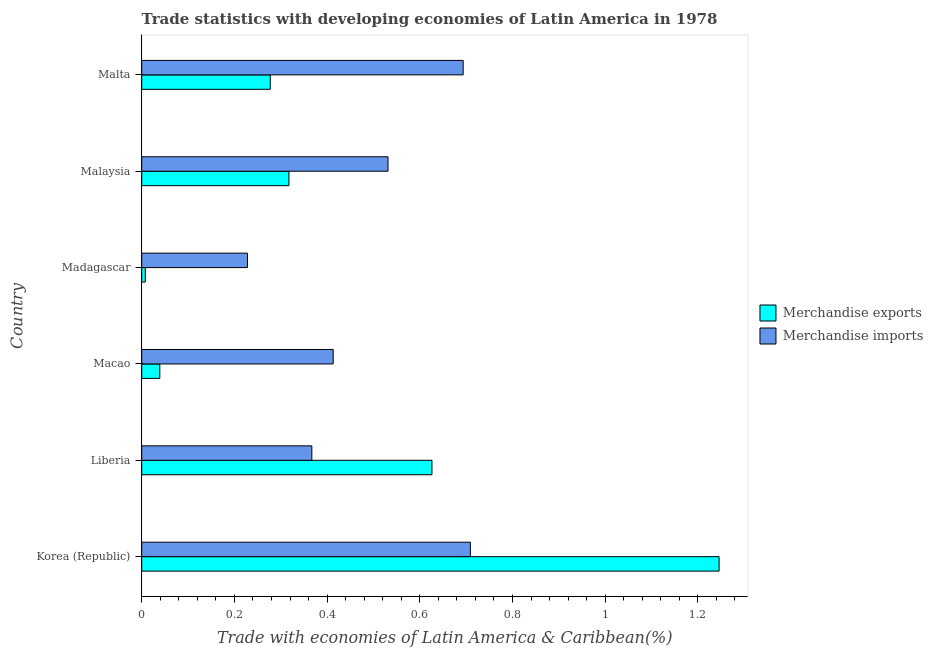How many different coloured bars are there?
Keep it short and to the point. 2. How many groups of bars are there?
Provide a short and direct response. 6. How many bars are there on the 5th tick from the top?
Keep it short and to the point. 2. How many bars are there on the 6th tick from the bottom?
Your answer should be compact. 2. What is the label of the 4th group of bars from the top?
Your answer should be very brief. Macao. What is the merchandise imports in Malta?
Provide a short and direct response. 0.69. Across all countries, what is the maximum merchandise imports?
Your answer should be very brief. 0.71. Across all countries, what is the minimum merchandise exports?
Your answer should be very brief. 0.01. In which country was the merchandise exports minimum?
Ensure brevity in your answer.  Madagascar. What is the total merchandise imports in the graph?
Ensure brevity in your answer.  2.94. What is the difference between the merchandise exports in Korea (Republic) and that in Malaysia?
Offer a very short reply. 0.93. What is the difference between the merchandise exports in Madagascar and the merchandise imports in Liberia?
Your answer should be compact. -0.36. What is the average merchandise exports per country?
Provide a short and direct response. 0.42. What is the difference between the merchandise exports and merchandise imports in Korea (Republic)?
Provide a short and direct response. 0.54. In how many countries, is the merchandise imports greater than 1 %?
Ensure brevity in your answer.  0. What is the ratio of the merchandise imports in Korea (Republic) to that in Liberia?
Provide a short and direct response. 1.93. Is the difference between the merchandise imports in Macao and Malta greater than the difference between the merchandise exports in Macao and Malta?
Your answer should be very brief. No. What is the difference between the highest and the second highest merchandise exports?
Offer a very short reply. 0.62. What is the difference between the highest and the lowest merchandise imports?
Your response must be concise. 0.48. In how many countries, is the merchandise exports greater than the average merchandise exports taken over all countries?
Your response must be concise. 2. What does the 1st bar from the top in Macao represents?
Offer a terse response. Merchandise imports. What does the 1st bar from the bottom in Liberia represents?
Offer a terse response. Merchandise exports. What is the difference between two consecutive major ticks on the X-axis?
Offer a very short reply. 0.2. Are the values on the major ticks of X-axis written in scientific E-notation?
Give a very brief answer. No. Does the graph contain any zero values?
Offer a very short reply. No. Where does the legend appear in the graph?
Provide a short and direct response. Center right. How many legend labels are there?
Provide a short and direct response. 2. How are the legend labels stacked?
Offer a terse response. Vertical. What is the title of the graph?
Your answer should be very brief. Trade statistics with developing economies of Latin America in 1978. Does "Secondary" appear as one of the legend labels in the graph?
Make the answer very short. No. What is the label or title of the X-axis?
Provide a short and direct response. Trade with economies of Latin America & Caribbean(%). What is the Trade with economies of Latin America & Caribbean(%) in Merchandise exports in Korea (Republic)?
Make the answer very short. 1.25. What is the Trade with economies of Latin America & Caribbean(%) of Merchandise imports in Korea (Republic)?
Offer a terse response. 0.71. What is the Trade with economies of Latin America & Caribbean(%) of Merchandise exports in Liberia?
Your response must be concise. 0.63. What is the Trade with economies of Latin America & Caribbean(%) of Merchandise imports in Liberia?
Offer a terse response. 0.37. What is the Trade with economies of Latin America & Caribbean(%) in Merchandise exports in Macao?
Ensure brevity in your answer.  0.04. What is the Trade with economies of Latin America & Caribbean(%) of Merchandise imports in Macao?
Keep it short and to the point. 0.41. What is the Trade with economies of Latin America & Caribbean(%) in Merchandise exports in Madagascar?
Your answer should be compact. 0.01. What is the Trade with economies of Latin America & Caribbean(%) of Merchandise imports in Madagascar?
Your answer should be compact. 0.23. What is the Trade with economies of Latin America & Caribbean(%) in Merchandise exports in Malaysia?
Your answer should be compact. 0.32. What is the Trade with economies of Latin America & Caribbean(%) in Merchandise imports in Malaysia?
Provide a short and direct response. 0.53. What is the Trade with economies of Latin America & Caribbean(%) of Merchandise exports in Malta?
Offer a terse response. 0.28. What is the Trade with economies of Latin America & Caribbean(%) in Merchandise imports in Malta?
Provide a short and direct response. 0.69. Across all countries, what is the maximum Trade with economies of Latin America & Caribbean(%) of Merchandise exports?
Ensure brevity in your answer.  1.25. Across all countries, what is the maximum Trade with economies of Latin America & Caribbean(%) of Merchandise imports?
Provide a succinct answer. 0.71. Across all countries, what is the minimum Trade with economies of Latin America & Caribbean(%) in Merchandise exports?
Offer a terse response. 0.01. Across all countries, what is the minimum Trade with economies of Latin America & Caribbean(%) in Merchandise imports?
Offer a terse response. 0.23. What is the total Trade with economies of Latin America & Caribbean(%) in Merchandise exports in the graph?
Your response must be concise. 2.51. What is the total Trade with economies of Latin America & Caribbean(%) of Merchandise imports in the graph?
Offer a very short reply. 2.94. What is the difference between the Trade with economies of Latin America & Caribbean(%) in Merchandise exports in Korea (Republic) and that in Liberia?
Your answer should be compact. 0.62. What is the difference between the Trade with economies of Latin America & Caribbean(%) in Merchandise imports in Korea (Republic) and that in Liberia?
Offer a terse response. 0.34. What is the difference between the Trade with economies of Latin America & Caribbean(%) in Merchandise exports in Korea (Republic) and that in Macao?
Ensure brevity in your answer.  1.21. What is the difference between the Trade with economies of Latin America & Caribbean(%) of Merchandise imports in Korea (Republic) and that in Macao?
Provide a short and direct response. 0.3. What is the difference between the Trade with economies of Latin America & Caribbean(%) of Merchandise exports in Korea (Republic) and that in Madagascar?
Give a very brief answer. 1.24. What is the difference between the Trade with economies of Latin America & Caribbean(%) in Merchandise imports in Korea (Republic) and that in Madagascar?
Give a very brief answer. 0.48. What is the difference between the Trade with economies of Latin America & Caribbean(%) of Merchandise exports in Korea (Republic) and that in Malaysia?
Give a very brief answer. 0.93. What is the difference between the Trade with economies of Latin America & Caribbean(%) of Merchandise imports in Korea (Republic) and that in Malaysia?
Keep it short and to the point. 0.18. What is the difference between the Trade with economies of Latin America & Caribbean(%) of Merchandise exports in Korea (Republic) and that in Malta?
Your response must be concise. 0.97. What is the difference between the Trade with economies of Latin America & Caribbean(%) in Merchandise imports in Korea (Republic) and that in Malta?
Give a very brief answer. 0.02. What is the difference between the Trade with economies of Latin America & Caribbean(%) of Merchandise exports in Liberia and that in Macao?
Make the answer very short. 0.59. What is the difference between the Trade with economies of Latin America & Caribbean(%) in Merchandise imports in Liberia and that in Macao?
Offer a terse response. -0.05. What is the difference between the Trade with economies of Latin America & Caribbean(%) in Merchandise exports in Liberia and that in Madagascar?
Keep it short and to the point. 0.62. What is the difference between the Trade with economies of Latin America & Caribbean(%) of Merchandise imports in Liberia and that in Madagascar?
Offer a terse response. 0.14. What is the difference between the Trade with economies of Latin America & Caribbean(%) in Merchandise exports in Liberia and that in Malaysia?
Make the answer very short. 0.31. What is the difference between the Trade with economies of Latin America & Caribbean(%) of Merchandise imports in Liberia and that in Malaysia?
Your answer should be very brief. -0.16. What is the difference between the Trade with economies of Latin America & Caribbean(%) in Merchandise exports in Liberia and that in Malta?
Your response must be concise. 0.35. What is the difference between the Trade with economies of Latin America & Caribbean(%) in Merchandise imports in Liberia and that in Malta?
Ensure brevity in your answer.  -0.33. What is the difference between the Trade with economies of Latin America & Caribbean(%) of Merchandise exports in Macao and that in Madagascar?
Make the answer very short. 0.03. What is the difference between the Trade with economies of Latin America & Caribbean(%) in Merchandise imports in Macao and that in Madagascar?
Provide a succinct answer. 0.18. What is the difference between the Trade with economies of Latin America & Caribbean(%) in Merchandise exports in Macao and that in Malaysia?
Provide a succinct answer. -0.28. What is the difference between the Trade with economies of Latin America & Caribbean(%) of Merchandise imports in Macao and that in Malaysia?
Offer a terse response. -0.12. What is the difference between the Trade with economies of Latin America & Caribbean(%) in Merchandise exports in Macao and that in Malta?
Provide a short and direct response. -0.24. What is the difference between the Trade with economies of Latin America & Caribbean(%) of Merchandise imports in Macao and that in Malta?
Offer a terse response. -0.28. What is the difference between the Trade with economies of Latin America & Caribbean(%) in Merchandise exports in Madagascar and that in Malaysia?
Keep it short and to the point. -0.31. What is the difference between the Trade with economies of Latin America & Caribbean(%) in Merchandise imports in Madagascar and that in Malaysia?
Make the answer very short. -0.3. What is the difference between the Trade with economies of Latin America & Caribbean(%) of Merchandise exports in Madagascar and that in Malta?
Offer a very short reply. -0.27. What is the difference between the Trade with economies of Latin America & Caribbean(%) in Merchandise imports in Madagascar and that in Malta?
Make the answer very short. -0.47. What is the difference between the Trade with economies of Latin America & Caribbean(%) in Merchandise exports in Malaysia and that in Malta?
Keep it short and to the point. 0.04. What is the difference between the Trade with economies of Latin America & Caribbean(%) of Merchandise imports in Malaysia and that in Malta?
Keep it short and to the point. -0.16. What is the difference between the Trade with economies of Latin America & Caribbean(%) of Merchandise exports in Korea (Republic) and the Trade with economies of Latin America & Caribbean(%) of Merchandise imports in Liberia?
Provide a succinct answer. 0.88. What is the difference between the Trade with economies of Latin America & Caribbean(%) in Merchandise exports in Korea (Republic) and the Trade with economies of Latin America & Caribbean(%) in Merchandise imports in Macao?
Offer a very short reply. 0.83. What is the difference between the Trade with economies of Latin America & Caribbean(%) in Merchandise exports in Korea (Republic) and the Trade with economies of Latin America & Caribbean(%) in Merchandise imports in Madagascar?
Your response must be concise. 1.02. What is the difference between the Trade with economies of Latin America & Caribbean(%) of Merchandise exports in Korea (Republic) and the Trade with economies of Latin America & Caribbean(%) of Merchandise imports in Malaysia?
Provide a succinct answer. 0.71. What is the difference between the Trade with economies of Latin America & Caribbean(%) in Merchandise exports in Korea (Republic) and the Trade with economies of Latin America & Caribbean(%) in Merchandise imports in Malta?
Ensure brevity in your answer.  0.55. What is the difference between the Trade with economies of Latin America & Caribbean(%) in Merchandise exports in Liberia and the Trade with economies of Latin America & Caribbean(%) in Merchandise imports in Macao?
Offer a terse response. 0.21. What is the difference between the Trade with economies of Latin America & Caribbean(%) in Merchandise exports in Liberia and the Trade with economies of Latin America & Caribbean(%) in Merchandise imports in Madagascar?
Make the answer very short. 0.4. What is the difference between the Trade with economies of Latin America & Caribbean(%) in Merchandise exports in Liberia and the Trade with economies of Latin America & Caribbean(%) in Merchandise imports in Malaysia?
Offer a very short reply. 0.09. What is the difference between the Trade with economies of Latin America & Caribbean(%) of Merchandise exports in Liberia and the Trade with economies of Latin America & Caribbean(%) of Merchandise imports in Malta?
Provide a succinct answer. -0.07. What is the difference between the Trade with economies of Latin America & Caribbean(%) in Merchandise exports in Macao and the Trade with economies of Latin America & Caribbean(%) in Merchandise imports in Madagascar?
Give a very brief answer. -0.19. What is the difference between the Trade with economies of Latin America & Caribbean(%) of Merchandise exports in Macao and the Trade with economies of Latin America & Caribbean(%) of Merchandise imports in Malaysia?
Your answer should be compact. -0.49. What is the difference between the Trade with economies of Latin America & Caribbean(%) of Merchandise exports in Macao and the Trade with economies of Latin America & Caribbean(%) of Merchandise imports in Malta?
Ensure brevity in your answer.  -0.65. What is the difference between the Trade with economies of Latin America & Caribbean(%) of Merchandise exports in Madagascar and the Trade with economies of Latin America & Caribbean(%) of Merchandise imports in Malaysia?
Offer a very short reply. -0.52. What is the difference between the Trade with economies of Latin America & Caribbean(%) of Merchandise exports in Madagascar and the Trade with economies of Latin America & Caribbean(%) of Merchandise imports in Malta?
Ensure brevity in your answer.  -0.69. What is the difference between the Trade with economies of Latin America & Caribbean(%) in Merchandise exports in Malaysia and the Trade with economies of Latin America & Caribbean(%) in Merchandise imports in Malta?
Your answer should be compact. -0.38. What is the average Trade with economies of Latin America & Caribbean(%) in Merchandise exports per country?
Your answer should be very brief. 0.42. What is the average Trade with economies of Latin America & Caribbean(%) in Merchandise imports per country?
Your response must be concise. 0.49. What is the difference between the Trade with economies of Latin America & Caribbean(%) in Merchandise exports and Trade with economies of Latin America & Caribbean(%) in Merchandise imports in Korea (Republic)?
Keep it short and to the point. 0.54. What is the difference between the Trade with economies of Latin America & Caribbean(%) in Merchandise exports and Trade with economies of Latin America & Caribbean(%) in Merchandise imports in Liberia?
Ensure brevity in your answer.  0.26. What is the difference between the Trade with economies of Latin America & Caribbean(%) of Merchandise exports and Trade with economies of Latin America & Caribbean(%) of Merchandise imports in Macao?
Offer a very short reply. -0.37. What is the difference between the Trade with economies of Latin America & Caribbean(%) in Merchandise exports and Trade with economies of Latin America & Caribbean(%) in Merchandise imports in Madagascar?
Offer a very short reply. -0.22. What is the difference between the Trade with economies of Latin America & Caribbean(%) of Merchandise exports and Trade with economies of Latin America & Caribbean(%) of Merchandise imports in Malaysia?
Your answer should be compact. -0.21. What is the difference between the Trade with economies of Latin America & Caribbean(%) in Merchandise exports and Trade with economies of Latin America & Caribbean(%) in Merchandise imports in Malta?
Your answer should be very brief. -0.42. What is the ratio of the Trade with economies of Latin America & Caribbean(%) of Merchandise exports in Korea (Republic) to that in Liberia?
Your answer should be compact. 1.99. What is the ratio of the Trade with economies of Latin America & Caribbean(%) in Merchandise imports in Korea (Republic) to that in Liberia?
Give a very brief answer. 1.93. What is the ratio of the Trade with economies of Latin America & Caribbean(%) of Merchandise exports in Korea (Republic) to that in Macao?
Offer a very short reply. 31.91. What is the ratio of the Trade with economies of Latin America & Caribbean(%) of Merchandise imports in Korea (Republic) to that in Macao?
Your answer should be very brief. 1.72. What is the ratio of the Trade with economies of Latin America & Caribbean(%) in Merchandise exports in Korea (Republic) to that in Madagascar?
Give a very brief answer. 161.49. What is the ratio of the Trade with economies of Latin America & Caribbean(%) in Merchandise imports in Korea (Republic) to that in Madagascar?
Provide a short and direct response. 3.11. What is the ratio of the Trade with economies of Latin America & Caribbean(%) in Merchandise exports in Korea (Republic) to that in Malaysia?
Offer a very short reply. 3.92. What is the ratio of the Trade with economies of Latin America & Caribbean(%) of Merchandise imports in Korea (Republic) to that in Malaysia?
Offer a terse response. 1.33. What is the ratio of the Trade with economies of Latin America & Caribbean(%) in Merchandise exports in Korea (Republic) to that in Malta?
Your answer should be very brief. 4.49. What is the ratio of the Trade with economies of Latin America & Caribbean(%) of Merchandise imports in Korea (Republic) to that in Malta?
Offer a terse response. 1.02. What is the ratio of the Trade with economies of Latin America & Caribbean(%) in Merchandise exports in Liberia to that in Macao?
Your answer should be compact. 16.04. What is the ratio of the Trade with economies of Latin America & Caribbean(%) in Merchandise imports in Liberia to that in Macao?
Your answer should be very brief. 0.89. What is the ratio of the Trade with economies of Latin America & Caribbean(%) of Merchandise exports in Liberia to that in Madagascar?
Your response must be concise. 81.18. What is the ratio of the Trade with economies of Latin America & Caribbean(%) in Merchandise imports in Liberia to that in Madagascar?
Your response must be concise. 1.61. What is the ratio of the Trade with economies of Latin America & Caribbean(%) of Merchandise exports in Liberia to that in Malaysia?
Provide a short and direct response. 1.97. What is the ratio of the Trade with economies of Latin America & Caribbean(%) in Merchandise imports in Liberia to that in Malaysia?
Give a very brief answer. 0.69. What is the ratio of the Trade with economies of Latin America & Caribbean(%) of Merchandise exports in Liberia to that in Malta?
Ensure brevity in your answer.  2.26. What is the ratio of the Trade with economies of Latin America & Caribbean(%) in Merchandise imports in Liberia to that in Malta?
Keep it short and to the point. 0.53. What is the ratio of the Trade with economies of Latin America & Caribbean(%) in Merchandise exports in Macao to that in Madagascar?
Your response must be concise. 5.06. What is the ratio of the Trade with economies of Latin America & Caribbean(%) of Merchandise imports in Macao to that in Madagascar?
Offer a very short reply. 1.81. What is the ratio of the Trade with economies of Latin America & Caribbean(%) of Merchandise exports in Macao to that in Malaysia?
Ensure brevity in your answer.  0.12. What is the ratio of the Trade with economies of Latin America & Caribbean(%) in Merchandise imports in Macao to that in Malaysia?
Give a very brief answer. 0.78. What is the ratio of the Trade with economies of Latin America & Caribbean(%) of Merchandise exports in Macao to that in Malta?
Your answer should be compact. 0.14. What is the ratio of the Trade with economies of Latin America & Caribbean(%) in Merchandise imports in Macao to that in Malta?
Make the answer very short. 0.6. What is the ratio of the Trade with economies of Latin America & Caribbean(%) in Merchandise exports in Madagascar to that in Malaysia?
Keep it short and to the point. 0.02. What is the ratio of the Trade with economies of Latin America & Caribbean(%) in Merchandise imports in Madagascar to that in Malaysia?
Your answer should be very brief. 0.43. What is the ratio of the Trade with economies of Latin America & Caribbean(%) of Merchandise exports in Madagascar to that in Malta?
Offer a terse response. 0.03. What is the ratio of the Trade with economies of Latin America & Caribbean(%) in Merchandise imports in Madagascar to that in Malta?
Offer a very short reply. 0.33. What is the ratio of the Trade with economies of Latin America & Caribbean(%) of Merchandise exports in Malaysia to that in Malta?
Give a very brief answer. 1.15. What is the ratio of the Trade with economies of Latin America & Caribbean(%) of Merchandise imports in Malaysia to that in Malta?
Offer a terse response. 0.77. What is the difference between the highest and the second highest Trade with economies of Latin America & Caribbean(%) of Merchandise exports?
Provide a short and direct response. 0.62. What is the difference between the highest and the second highest Trade with economies of Latin America & Caribbean(%) in Merchandise imports?
Ensure brevity in your answer.  0.02. What is the difference between the highest and the lowest Trade with economies of Latin America & Caribbean(%) in Merchandise exports?
Provide a succinct answer. 1.24. What is the difference between the highest and the lowest Trade with economies of Latin America & Caribbean(%) of Merchandise imports?
Keep it short and to the point. 0.48. 